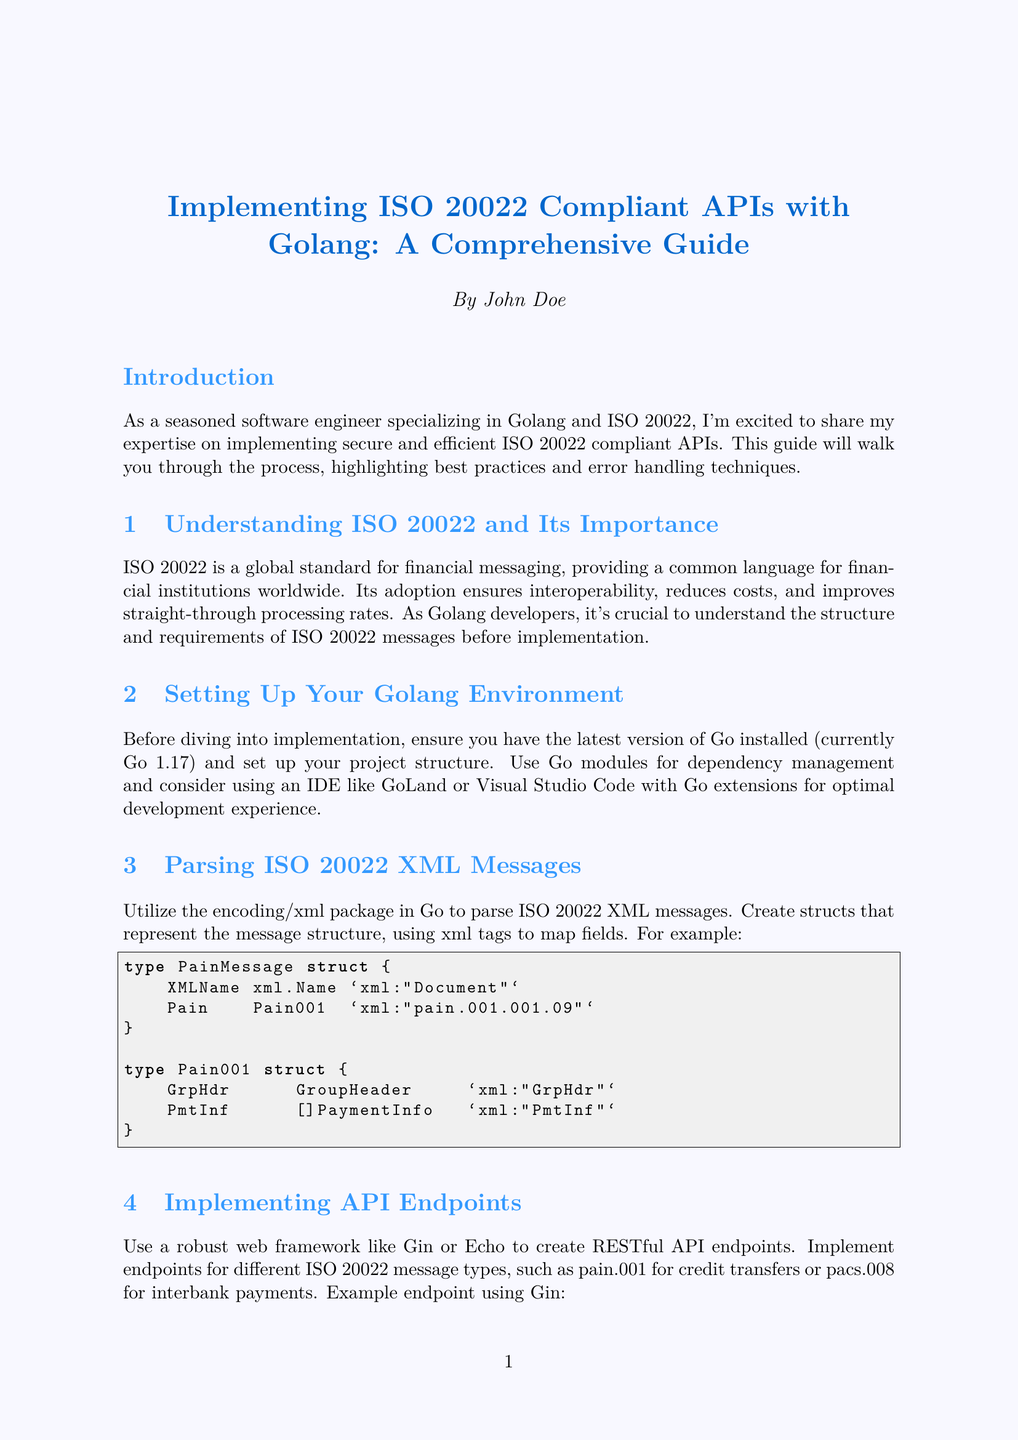What is the title of the newsletter? The title of the newsletter is mentioned at the beginning and serves as the main focus of the document.
Answer: Implementing ISO 20022 Compliant APIs with Golang: A Comprehensive Guide Who is the author of the newsletter? The author is credited at the end of the document, providing credibility to the content shared.
Answer: John Doe What version of Go is recommended for the environment setup? The version is explicitly stated in the section about setting up the environment.
Answer: Go 1.17 What is one of the recommended security practices? Security practices are listed under their relevant section, showcasing necessary measures for API security.
Answer: Use HTTPS with TLS 1.3 for all communications Which structured logging library is suggested for error handling? The document mentions specific libraries under the error handling section that can be utilized.
Answer: Zap or Logrus What is the purpose of ISO 20022? The importance and purpose of ISO 20022 is discussed in the introduction of the document.
Answer: Provides a common language for financial institutions How can one stay updated with ISO 20022 standards? The document provides a list of strategies to remain compliant with the evolving standards, grouped within a section.
Answer: Subscribing to ISO 20022 newsletters What testing tools are mentioned for manual API testing? The section on testing provides specific tools that can be used for this purpose, illustrating a practical approach for developers.
Answer: Postman or curl What should be implemented for centralized error handling? Centralized error handling is discussed within the context of improving overall application reliability, specifying an implementation approach.
Answer: Middleware 